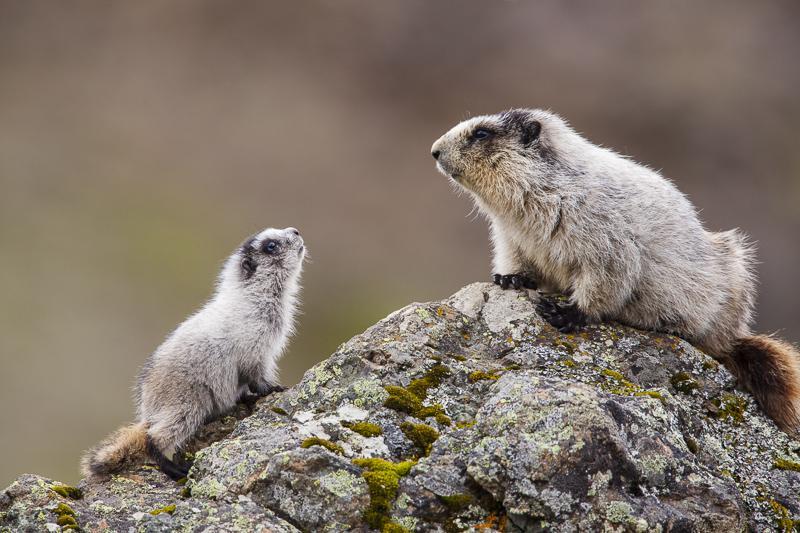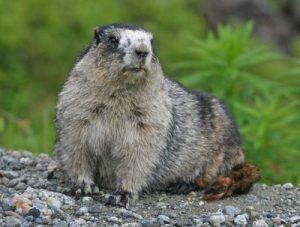The first image is the image on the left, the second image is the image on the right. Assess this claim about the two images: "The marmots are all a similar color.". Correct or not? Answer yes or no. Yes. The first image is the image on the left, the second image is the image on the right. Given the left and right images, does the statement "There are no more than two rodents." hold true? Answer yes or no. No. 